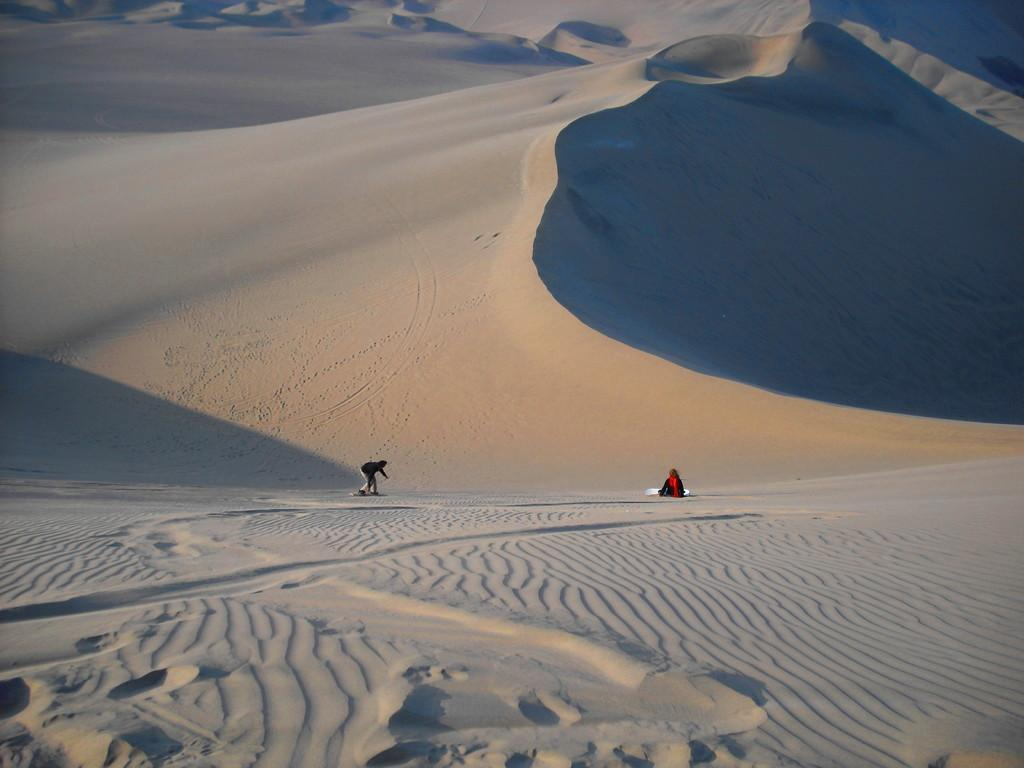How many people are in the image? There are two persons in the image. What is the setting of the image? The image depicts a desert setting. What type of playground equipment can be seen in the image? There is no playground equipment present in the image, as it depicts a desert setting. What type of skirt is the person on the left wearing in the image? There is no skirt visible in the image, as both persons are dressed in clothing suitable for a desert environment. 